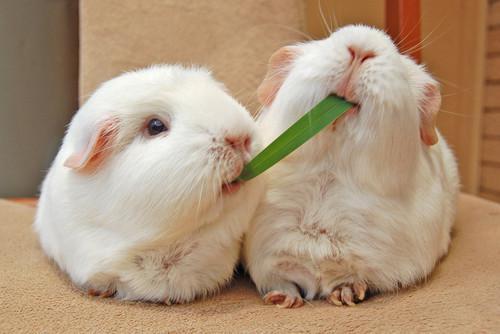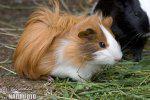The first image is the image on the left, the second image is the image on the right. Assess this claim about the two images: "There are two rodents". Correct or not? Answer yes or no. No. 